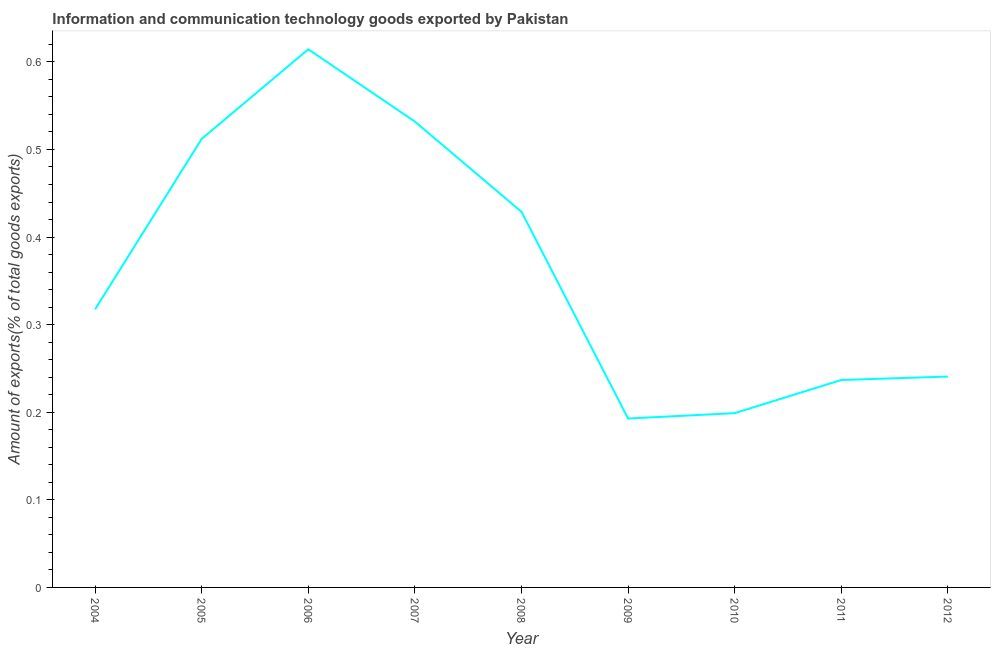What is the amount of ict goods exports in 2012?
Your answer should be very brief. 0.24. Across all years, what is the maximum amount of ict goods exports?
Keep it short and to the point. 0.61. Across all years, what is the minimum amount of ict goods exports?
Ensure brevity in your answer.  0.19. What is the sum of the amount of ict goods exports?
Make the answer very short. 3.27. What is the difference between the amount of ict goods exports in 2004 and 2006?
Provide a short and direct response. -0.3. What is the average amount of ict goods exports per year?
Give a very brief answer. 0.36. What is the median amount of ict goods exports?
Your response must be concise. 0.32. Do a majority of the years between 2010 and 2011 (inclusive) have amount of ict goods exports greater than 0.46 %?
Offer a terse response. No. What is the ratio of the amount of ict goods exports in 2005 to that in 2012?
Offer a very short reply. 2.13. Is the amount of ict goods exports in 2006 less than that in 2008?
Offer a very short reply. No. Is the difference between the amount of ict goods exports in 2004 and 2008 greater than the difference between any two years?
Keep it short and to the point. No. What is the difference between the highest and the second highest amount of ict goods exports?
Offer a very short reply. 0.08. Is the sum of the amount of ict goods exports in 2007 and 2011 greater than the maximum amount of ict goods exports across all years?
Your answer should be compact. Yes. What is the difference between the highest and the lowest amount of ict goods exports?
Make the answer very short. 0.42. What is the difference between two consecutive major ticks on the Y-axis?
Keep it short and to the point. 0.1. Does the graph contain any zero values?
Keep it short and to the point. No. Does the graph contain grids?
Provide a short and direct response. No. What is the title of the graph?
Your answer should be compact. Information and communication technology goods exported by Pakistan. What is the label or title of the Y-axis?
Keep it short and to the point. Amount of exports(% of total goods exports). What is the Amount of exports(% of total goods exports) in 2004?
Your answer should be very brief. 0.32. What is the Amount of exports(% of total goods exports) of 2005?
Give a very brief answer. 0.51. What is the Amount of exports(% of total goods exports) of 2006?
Keep it short and to the point. 0.61. What is the Amount of exports(% of total goods exports) in 2007?
Your response must be concise. 0.53. What is the Amount of exports(% of total goods exports) of 2008?
Provide a short and direct response. 0.43. What is the Amount of exports(% of total goods exports) of 2009?
Ensure brevity in your answer.  0.19. What is the Amount of exports(% of total goods exports) of 2010?
Give a very brief answer. 0.2. What is the Amount of exports(% of total goods exports) in 2011?
Your answer should be compact. 0.24. What is the Amount of exports(% of total goods exports) of 2012?
Give a very brief answer. 0.24. What is the difference between the Amount of exports(% of total goods exports) in 2004 and 2005?
Offer a very short reply. -0.19. What is the difference between the Amount of exports(% of total goods exports) in 2004 and 2006?
Offer a terse response. -0.3. What is the difference between the Amount of exports(% of total goods exports) in 2004 and 2007?
Your response must be concise. -0.21. What is the difference between the Amount of exports(% of total goods exports) in 2004 and 2008?
Provide a short and direct response. -0.11. What is the difference between the Amount of exports(% of total goods exports) in 2004 and 2009?
Provide a short and direct response. 0.12. What is the difference between the Amount of exports(% of total goods exports) in 2004 and 2010?
Your answer should be compact. 0.12. What is the difference between the Amount of exports(% of total goods exports) in 2004 and 2011?
Provide a succinct answer. 0.08. What is the difference between the Amount of exports(% of total goods exports) in 2004 and 2012?
Offer a very short reply. 0.08. What is the difference between the Amount of exports(% of total goods exports) in 2005 and 2006?
Your answer should be very brief. -0.1. What is the difference between the Amount of exports(% of total goods exports) in 2005 and 2007?
Keep it short and to the point. -0.02. What is the difference between the Amount of exports(% of total goods exports) in 2005 and 2008?
Your response must be concise. 0.08. What is the difference between the Amount of exports(% of total goods exports) in 2005 and 2009?
Your answer should be compact. 0.32. What is the difference between the Amount of exports(% of total goods exports) in 2005 and 2010?
Provide a short and direct response. 0.31. What is the difference between the Amount of exports(% of total goods exports) in 2005 and 2011?
Your answer should be very brief. 0.28. What is the difference between the Amount of exports(% of total goods exports) in 2005 and 2012?
Offer a very short reply. 0.27. What is the difference between the Amount of exports(% of total goods exports) in 2006 and 2007?
Offer a terse response. 0.08. What is the difference between the Amount of exports(% of total goods exports) in 2006 and 2008?
Provide a succinct answer. 0.19. What is the difference between the Amount of exports(% of total goods exports) in 2006 and 2009?
Your answer should be very brief. 0.42. What is the difference between the Amount of exports(% of total goods exports) in 2006 and 2010?
Offer a very short reply. 0.42. What is the difference between the Amount of exports(% of total goods exports) in 2006 and 2011?
Provide a succinct answer. 0.38. What is the difference between the Amount of exports(% of total goods exports) in 2006 and 2012?
Your answer should be very brief. 0.37. What is the difference between the Amount of exports(% of total goods exports) in 2007 and 2008?
Offer a terse response. 0.1. What is the difference between the Amount of exports(% of total goods exports) in 2007 and 2009?
Give a very brief answer. 0.34. What is the difference between the Amount of exports(% of total goods exports) in 2007 and 2010?
Offer a very short reply. 0.33. What is the difference between the Amount of exports(% of total goods exports) in 2007 and 2011?
Keep it short and to the point. 0.3. What is the difference between the Amount of exports(% of total goods exports) in 2007 and 2012?
Make the answer very short. 0.29. What is the difference between the Amount of exports(% of total goods exports) in 2008 and 2009?
Your answer should be compact. 0.24. What is the difference between the Amount of exports(% of total goods exports) in 2008 and 2010?
Ensure brevity in your answer.  0.23. What is the difference between the Amount of exports(% of total goods exports) in 2008 and 2011?
Provide a short and direct response. 0.19. What is the difference between the Amount of exports(% of total goods exports) in 2008 and 2012?
Your answer should be very brief. 0.19. What is the difference between the Amount of exports(% of total goods exports) in 2009 and 2010?
Make the answer very short. -0.01. What is the difference between the Amount of exports(% of total goods exports) in 2009 and 2011?
Your answer should be compact. -0.04. What is the difference between the Amount of exports(% of total goods exports) in 2009 and 2012?
Keep it short and to the point. -0.05. What is the difference between the Amount of exports(% of total goods exports) in 2010 and 2011?
Ensure brevity in your answer.  -0.04. What is the difference between the Amount of exports(% of total goods exports) in 2010 and 2012?
Provide a succinct answer. -0.04. What is the difference between the Amount of exports(% of total goods exports) in 2011 and 2012?
Give a very brief answer. -0. What is the ratio of the Amount of exports(% of total goods exports) in 2004 to that in 2005?
Your answer should be compact. 0.62. What is the ratio of the Amount of exports(% of total goods exports) in 2004 to that in 2006?
Your answer should be very brief. 0.52. What is the ratio of the Amount of exports(% of total goods exports) in 2004 to that in 2007?
Provide a short and direct response. 0.6. What is the ratio of the Amount of exports(% of total goods exports) in 2004 to that in 2008?
Offer a terse response. 0.74. What is the ratio of the Amount of exports(% of total goods exports) in 2004 to that in 2009?
Your answer should be compact. 1.65. What is the ratio of the Amount of exports(% of total goods exports) in 2004 to that in 2010?
Ensure brevity in your answer.  1.6. What is the ratio of the Amount of exports(% of total goods exports) in 2004 to that in 2011?
Offer a terse response. 1.34. What is the ratio of the Amount of exports(% of total goods exports) in 2004 to that in 2012?
Offer a terse response. 1.32. What is the ratio of the Amount of exports(% of total goods exports) in 2005 to that in 2006?
Give a very brief answer. 0.83. What is the ratio of the Amount of exports(% of total goods exports) in 2005 to that in 2008?
Keep it short and to the point. 1.19. What is the ratio of the Amount of exports(% of total goods exports) in 2005 to that in 2009?
Offer a terse response. 2.66. What is the ratio of the Amount of exports(% of total goods exports) in 2005 to that in 2010?
Give a very brief answer. 2.57. What is the ratio of the Amount of exports(% of total goods exports) in 2005 to that in 2011?
Give a very brief answer. 2.16. What is the ratio of the Amount of exports(% of total goods exports) in 2005 to that in 2012?
Your answer should be compact. 2.13. What is the ratio of the Amount of exports(% of total goods exports) in 2006 to that in 2007?
Keep it short and to the point. 1.16. What is the ratio of the Amount of exports(% of total goods exports) in 2006 to that in 2008?
Offer a very short reply. 1.43. What is the ratio of the Amount of exports(% of total goods exports) in 2006 to that in 2009?
Your answer should be very brief. 3.19. What is the ratio of the Amount of exports(% of total goods exports) in 2006 to that in 2010?
Provide a succinct answer. 3.09. What is the ratio of the Amount of exports(% of total goods exports) in 2006 to that in 2011?
Offer a terse response. 2.59. What is the ratio of the Amount of exports(% of total goods exports) in 2006 to that in 2012?
Give a very brief answer. 2.55. What is the ratio of the Amount of exports(% of total goods exports) in 2007 to that in 2008?
Keep it short and to the point. 1.24. What is the ratio of the Amount of exports(% of total goods exports) in 2007 to that in 2009?
Ensure brevity in your answer.  2.76. What is the ratio of the Amount of exports(% of total goods exports) in 2007 to that in 2010?
Your answer should be very brief. 2.67. What is the ratio of the Amount of exports(% of total goods exports) in 2007 to that in 2011?
Your answer should be very brief. 2.25. What is the ratio of the Amount of exports(% of total goods exports) in 2007 to that in 2012?
Give a very brief answer. 2.21. What is the ratio of the Amount of exports(% of total goods exports) in 2008 to that in 2009?
Offer a very short reply. 2.22. What is the ratio of the Amount of exports(% of total goods exports) in 2008 to that in 2010?
Offer a terse response. 2.15. What is the ratio of the Amount of exports(% of total goods exports) in 2008 to that in 2011?
Provide a short and direct response. 1.81. What is the ratio of the Amount of exports(% of total goods exports) in 2008 to that in 2012?
Your answer should be very brief. 1.78. What is the ratio of the Amount of exports(% of total goods exports) in 2009 to that in 2010?
Your answer should be very brief. 0.97. What is the ratio of the Amount of exports(% of total goods exports) in 2009 to that in 2011?
Give a very brief answer. 0.81. What is the ratio of the Amount of exports(% of total goods exports) in 2009 to that in 2012?
Your answer should be compact. 0.8. What is the ratio of the Amount of exports(% of total goods exports) in 2010 to that in 2011?
Offer a very short reply. 0.84. What is the ratio of the Amount of exports(% of total goods exports) in 2010 to that in 2012?
Ensure brevity in your answer.  0.83. 